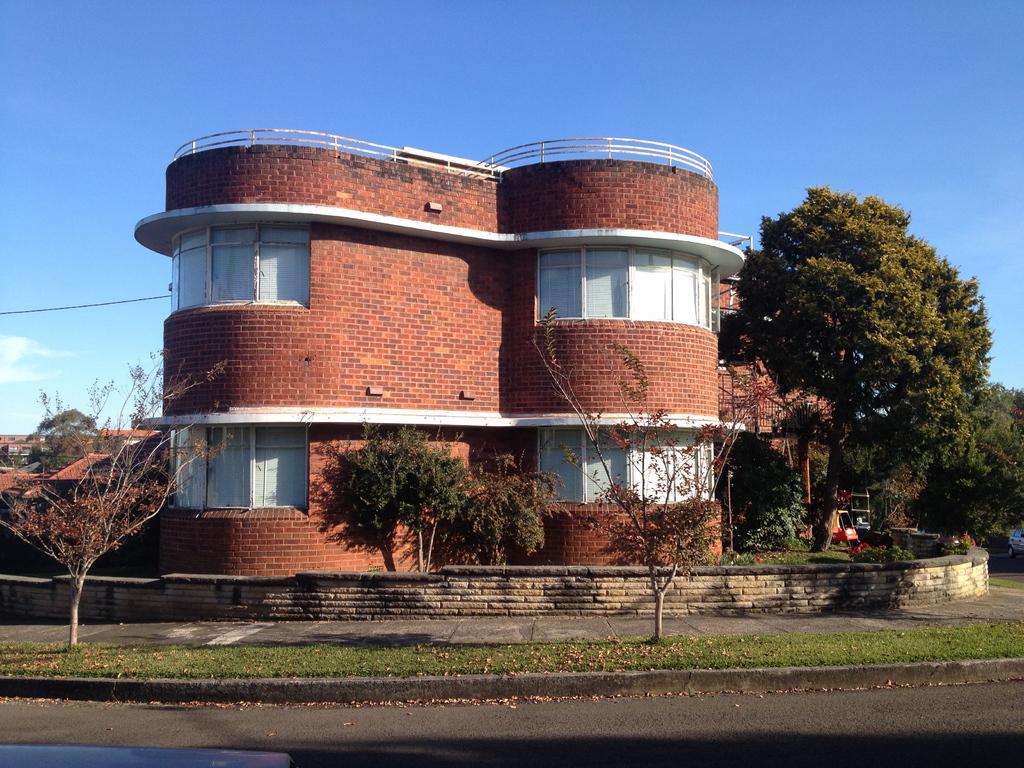Could you give a brief overview of what you see in this image? In the foreground of this image, there is a road and on the left bottom, there is a vehicle top. In the background, there is a grass, pavement, tiny wall, trees, buildings, a cable, sky and the cloud. 